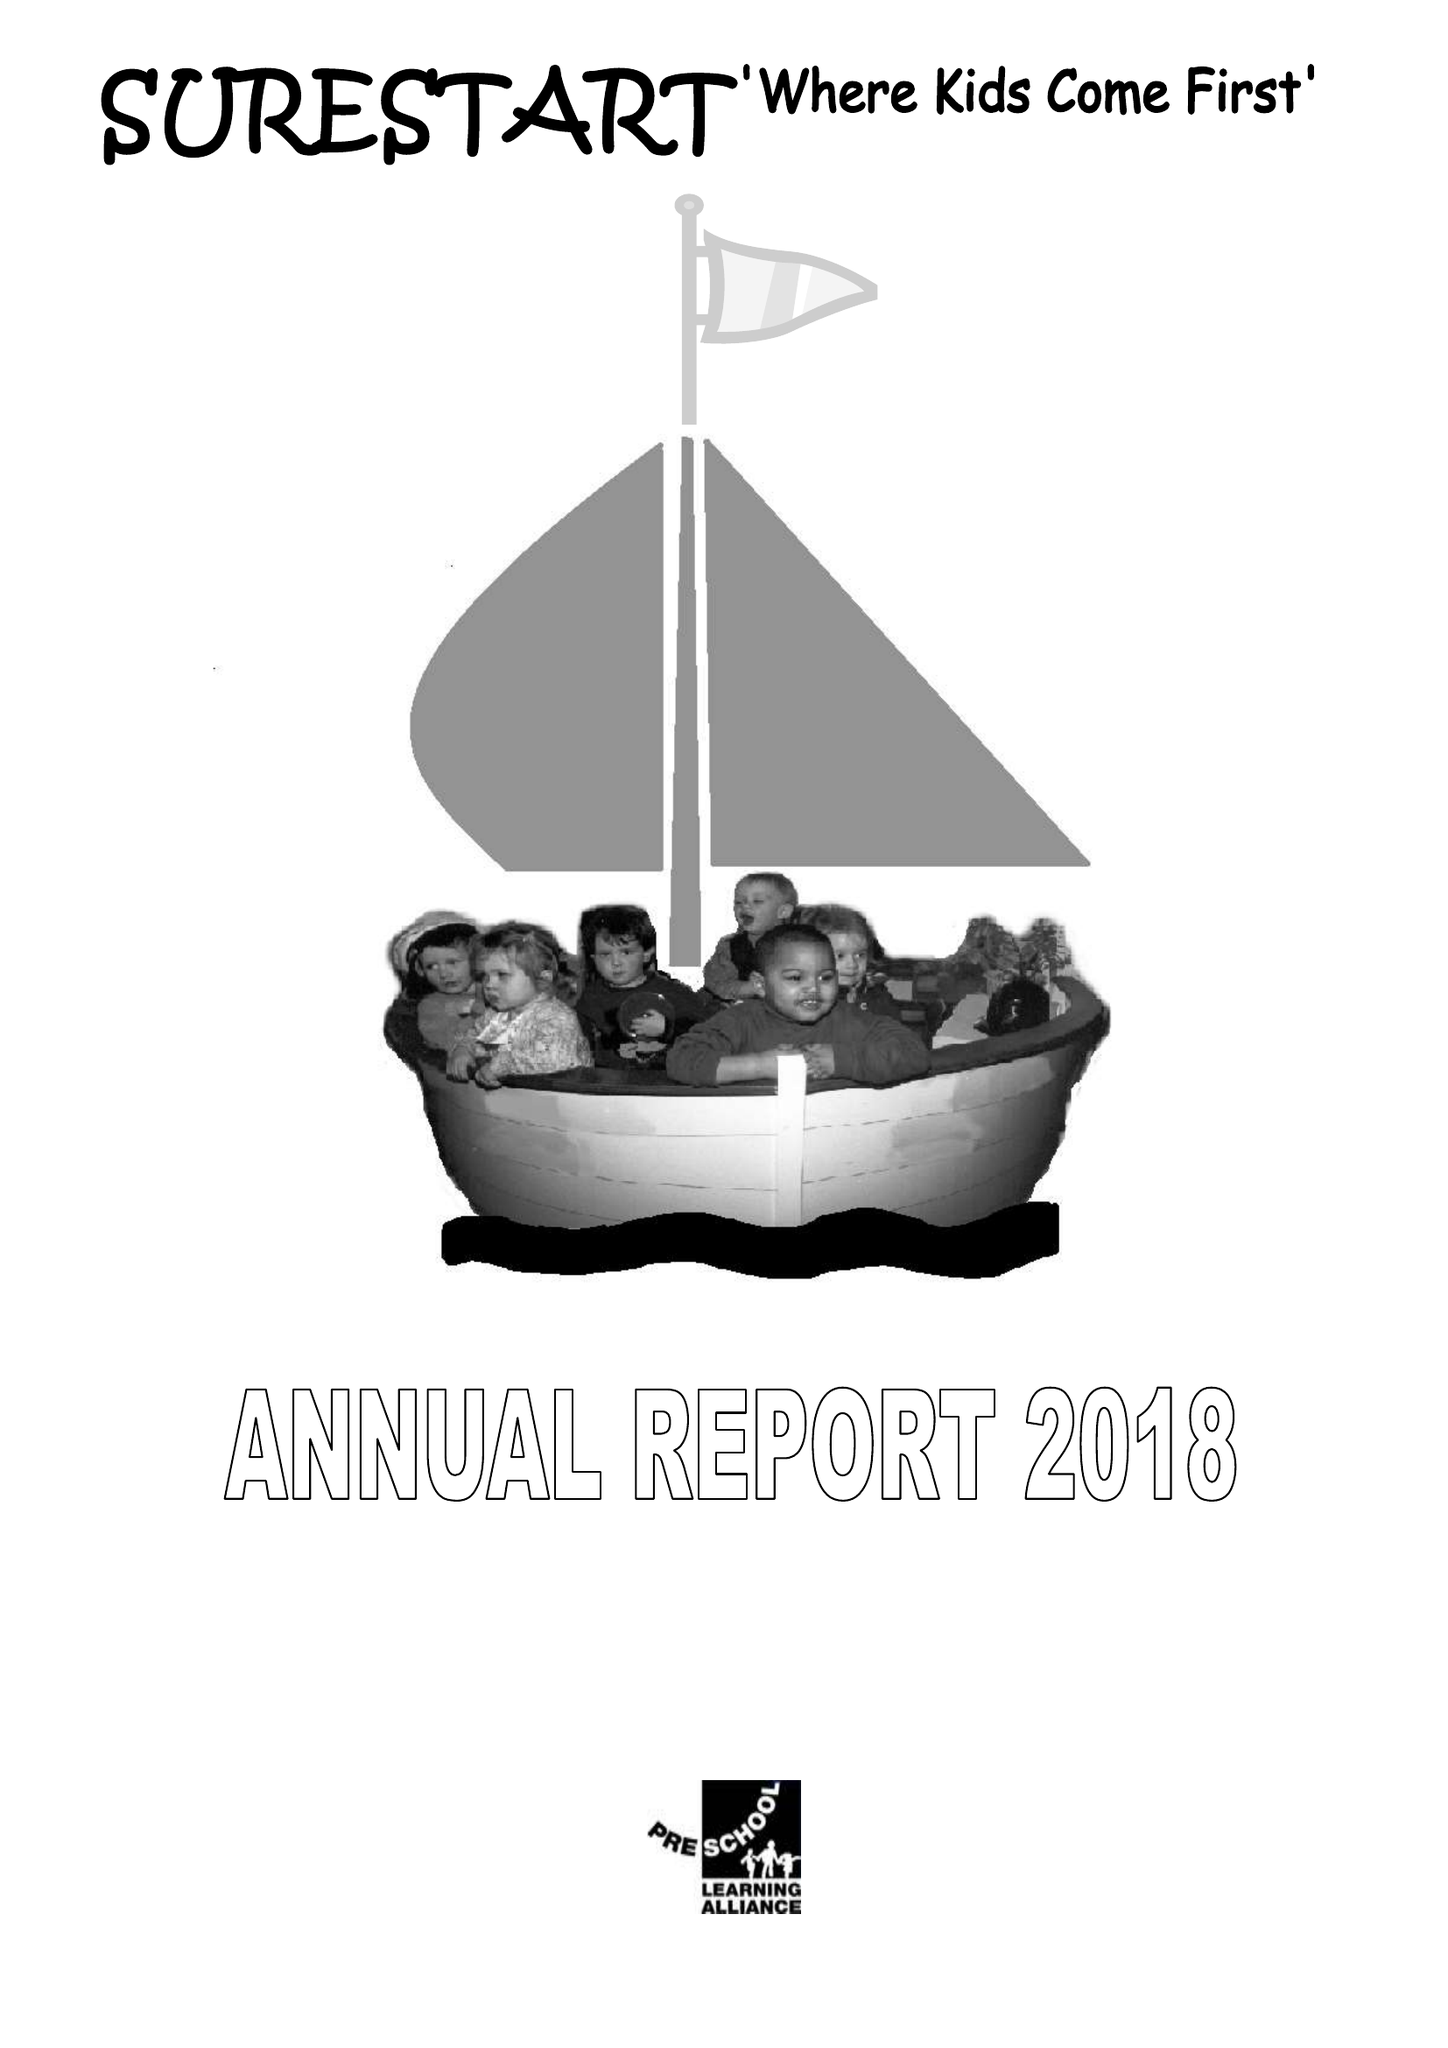What is the value for the address__post_town?
Answer the question using a single word or phrase. None 